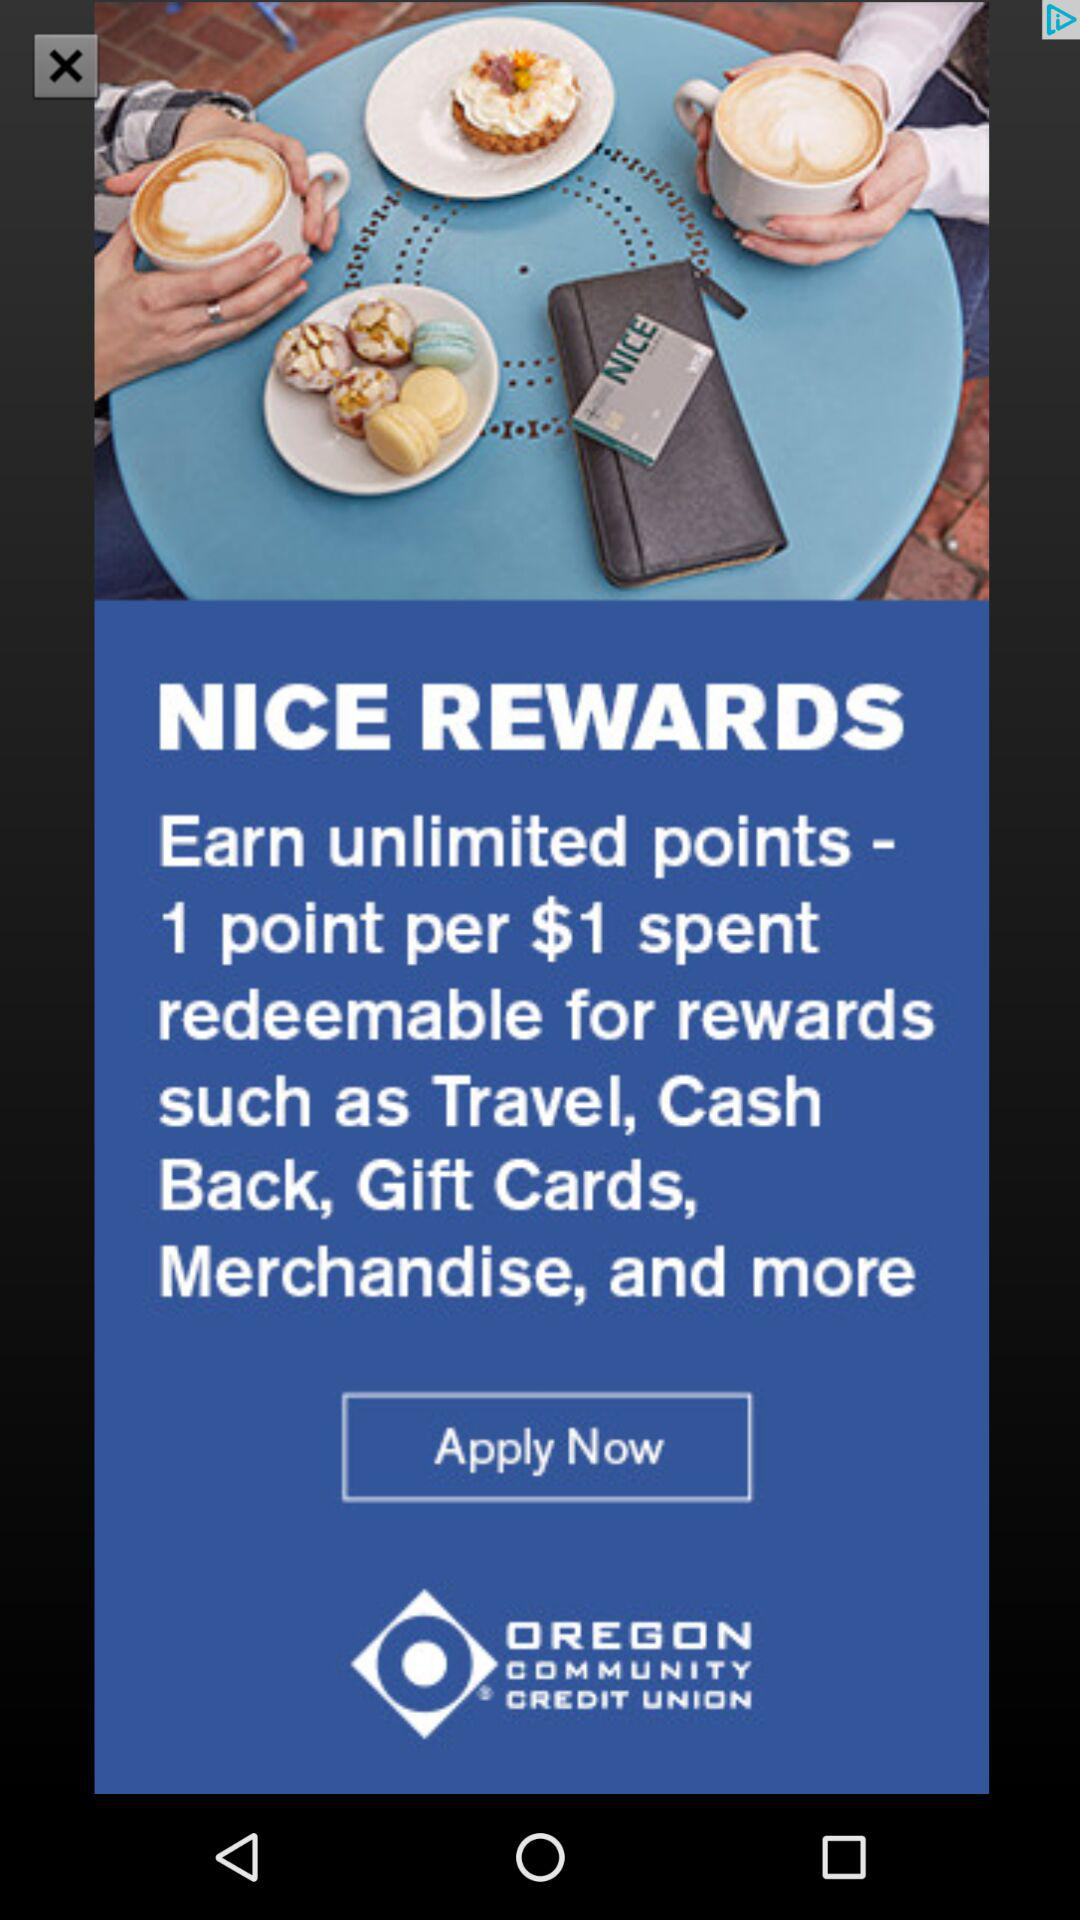How much is one point equal to?
When the provided information is insufficient, respond with <no answer>. <no answer> 